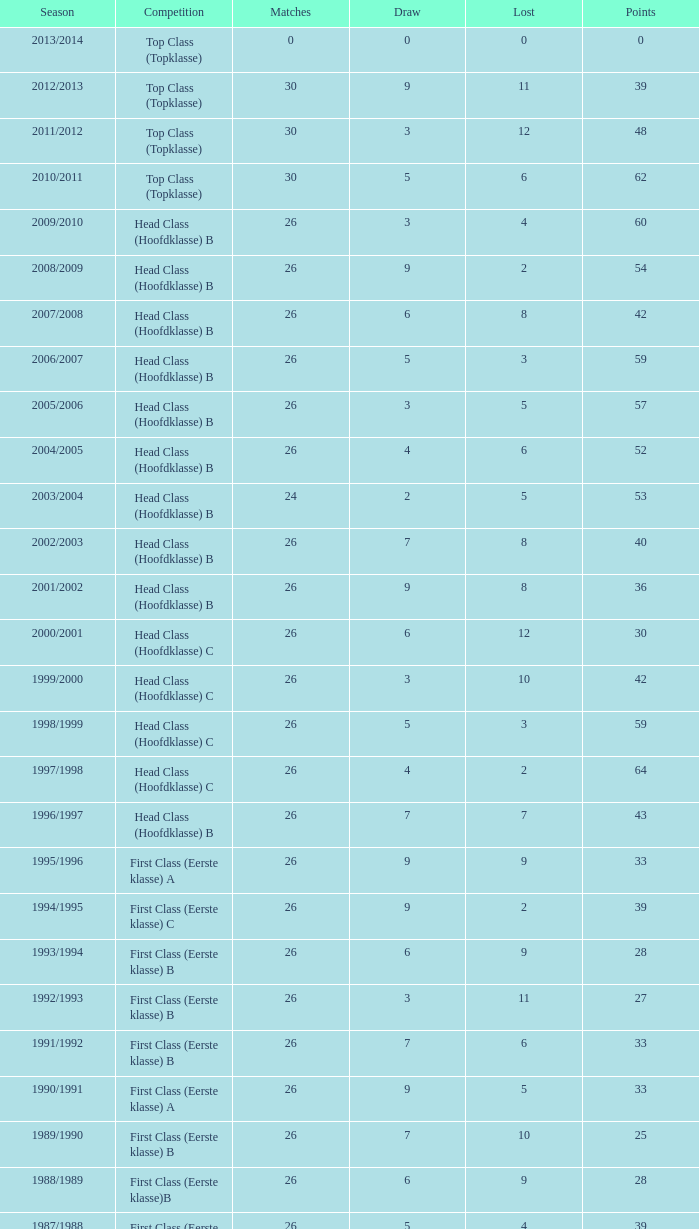What is the total number of matches with a loss less than 5 in the 2008/2009 season and has a draw larger than 9? 0.0. 